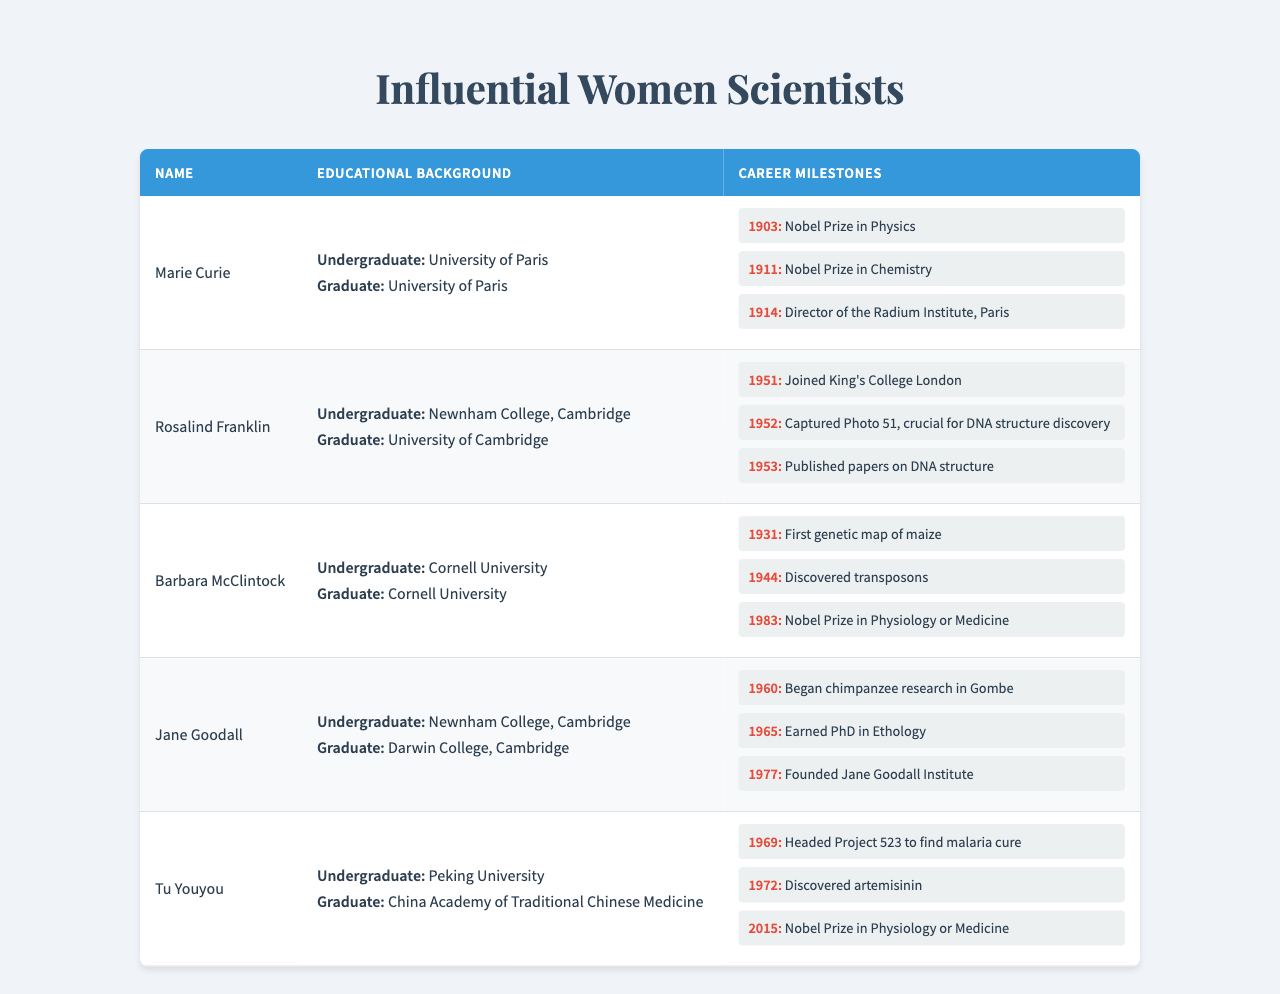What undergraduate institution did Marie Curie attend? According to the table, Marie Curie attended the University of Paris for her undergraduate education.
Answer: University of Paris How many Nobel Prizes did Rosalind Franklin achieve? The table indicates that Rosalind Franklin did not win any Nobel Prizes, as her achievements listed do not include any Nobel Prize.
Answer: 0 Which scientist discovered transposons? The milestone for Barbara McClintock in 1944 states that she discovered transposons, making her the scientist responsible for this achievement.
Answer: Barbara McClintock What was the highest achievement attained by Tu Youyou, and in what year? Looking at Tu Youyou's milestones, the highest achievement listed is the Nobel Prize in Physiology or Medicine, which she received in 2015.
Answer: Nobel Prize in Physiology or Medicine in 2015 Which two scientists attended Newnham College, Cambridge for their undergraduate studies? By reviewing the educational backgrounds, both Rosalind Franklin and Jane Goodall graduated from Newnham College, Cambridge, as indicated in the table.
Answer: Rosalind Franklin and Jane Goodall How many career milestones did Jane Goodall have? The table shows that Jane Goodall has three career milestones listed in the achievements section, one for each major event related to her research and recognition.
Answer: 3 Did any of the scientists listed receive a Nobel Prize in the field of Chemistry? The table shows that Marie Curie received a Nobel Prize in Chemistry in 1911, confirming that at least one scientist received a Nobel Prize in that field.
Answer: Yes Which scientist has educational qualifications from Cornell University? According to the educational background section of the table, Barbara McClintock attended Cornell University for both her undergraduate and graduate studies.
Answer: Barbara McClintock What was the significant contribution of Rosalind Franklin in 1952? The table mentions that Rosalind Franklin captured Photo 51 in 1952, which was crucial for the discovery of the DNA structure.
Answer: Captured Photo 51 How many years were there between Tu Youyou's discovery of artemisinin and her receiving the Nobel Prize? Tu Youyou discovered artemisinin in 1972 and received the Nobel Prize in 2015. The difference in years is 2015 - 1972 = 43 years.
Answer: 43 years 